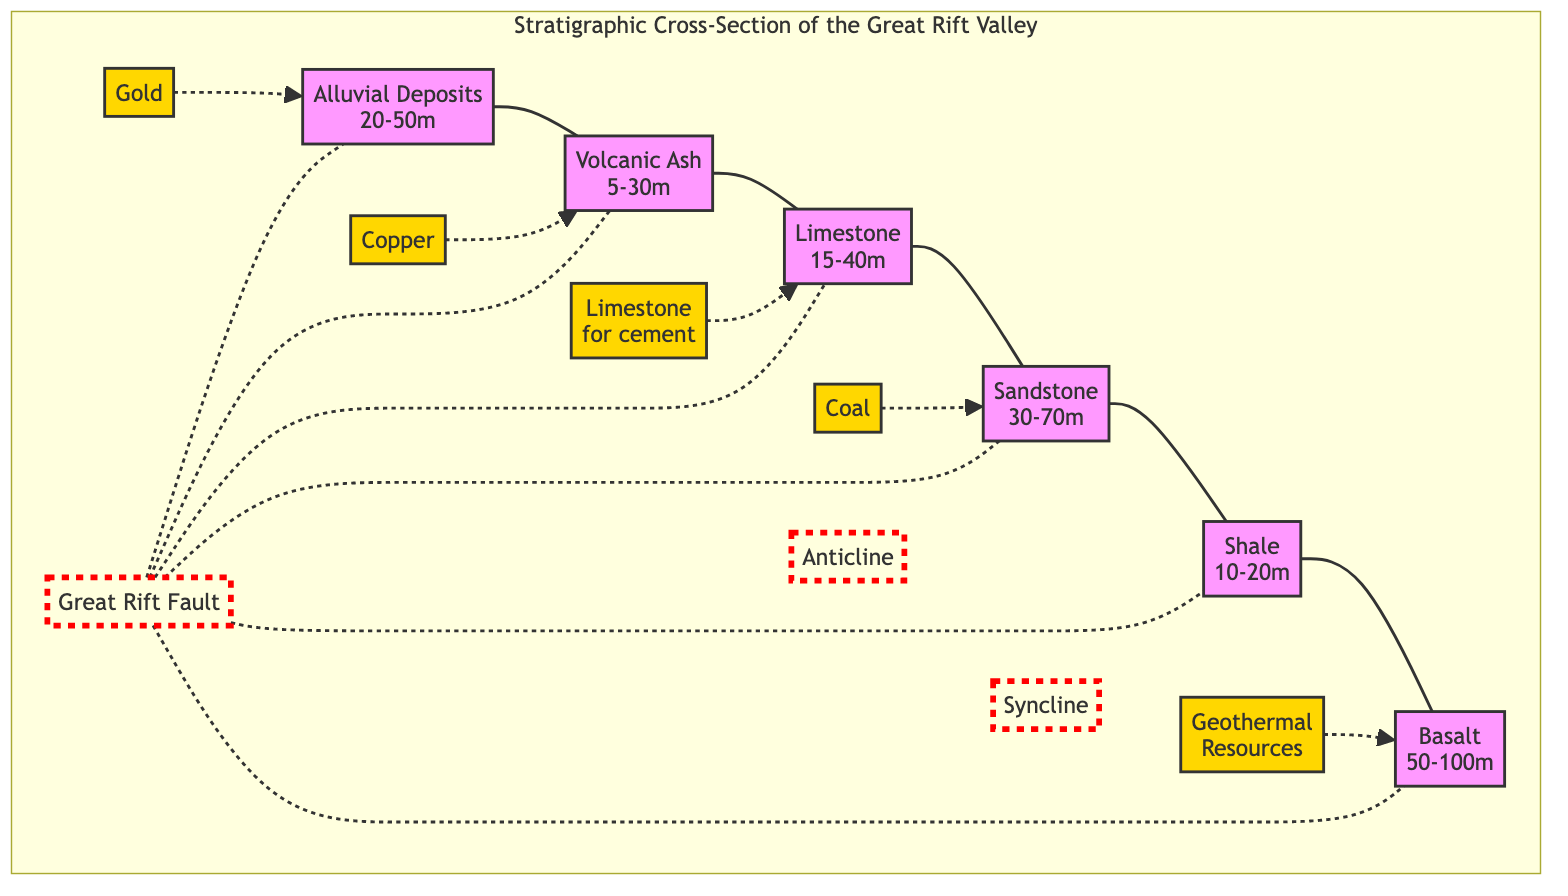What is the deepest geological layer in the Great Rift Valley? The deepest geological layer is the Basalt layer, which ranges from 50-100 meters in depth. I identified the Basalt layer at the bottom of the stratigraphic cross-section, indicating its position as the deepest layer.
Answer: Basalt Which mineral deposit is associated with the Alluvial Deposits? The mineral deposit associated with the Alluvial Deposits is Gold. I found the Gold deposit connected with a dashed line to the Alluvial Deposits layer in the diagram, indicating a relationship.
Answer: Gold How many types of mineral deposits are represented in the diagram? There are five types of mineral deposits represented in the diagram: Gold, Copper, Limestone for cement, Coal, and Geothermal Resources. I counted each mineral deposit listed in the diagram's legend.
Answer: 5 What geological feature is represented by the Great Rift Fault? The Great Rift Fault is represented as a fault line in the diagram, shown prominently in red and connecting with all layers. It visually represents a significant structural feature indicating movement in the crust.
Answer: Fault Which sedimentary layer is located directly above Shale? The sandstone layer is located directly above Shale. By visually tracing the layers from bottom to top in the diagram, I identified the sequence of layers.
Answer: Sandstone Which sedimentary layer contains Limestone for cement? The Limestone layer contains Limestone for cement. The diagram explicitly indicates that the Limestone layer is associated with that particular mineral deposit.
Answer: Limestone Are the Coal deposits associated with a fault? Yes, the Coal deposits are associated with the Great Rift Fault. This is shown in the diagram with a dashed connection from the Coal deposit to the fault line, indicating its relationship.
Answer: Yes What type of resource is linked with the Basalt layer? The Geothermal Resources are linked with the Basalt layer. I noted the dashed connection between the Geothermal Resources and the Basalt layer in the diagram, indicating that they are related.
Answer: Geothermal Resources What is the thickness range of the Volcanic Ash layer? The thickness range of the Volcanic Ash layer is 5-30 meters. In the diagram, the Volcanic Ash is labeled with this specific range, providing the needed information.
Answer: 5-30m 